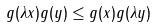<formula> <loc_0><loc_0><loc_500><loc_500>g ( \lambda x ) g ( y ) \leq g ( x ) g ( \lambda y )</formula> 